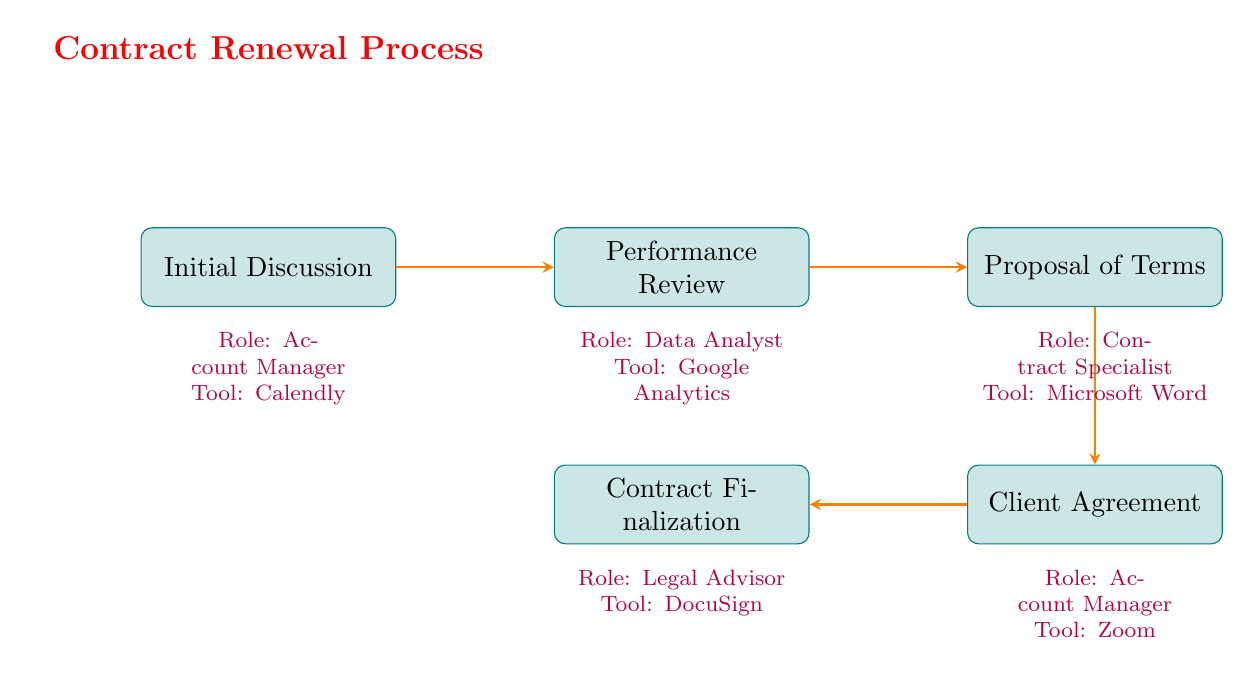What is the first stage in the contract renewal process? According to the diagram, the first stage listed is "Initial Discussion." This can be identified as it is the leftmost node in the flow chart.
Answer: Initial Discussion Who is responsible for the Performance Review? The diagram indicates that the role responsible for the Performance Review stage is the "Data Analyst." This is shown directly below the Performance Review node.
Answer: Data Analyst What tool is used during the Proposal of Terms stage? The diagram specifies that the tool used in the Proposal of Terms stage is "Microsoft Word." This information is underneath the corresponding node in the chart.
Answer: Microsoft Word How many stages are involved in the contract renewal process? The diagram clearly shows five distinct stages. Counting the nodes from left to right gives a total of five stages: Initial Discussion, Performance Review, Proposal of Terms, Client Agreement, and Contract Finalization.
Answer: 5 What is the last stage before Contract Finalization? Looking at the flow, the stage that comes immediately before Contract Finalization is "Client Agreement." This is indicated as the node that is directly above the final stage in the diagram.
Answer: Client Agreement What is the relationship between Proposal of Terms and Contract Finalization? The Proposal of Terms stage precedes the Client Agreement, which in turn leads to Contract Finalization. The arrows in the diagram indicate a sequential flow from Proposal of Terms down to Contract Finalization.
Answer: Sequential Which two roles are the same in the diagram? Both the "Account Manager" roles appear in the Initial Discussion and Client Agreement stages as indicated below each of those nodes.
Answer: Account Manager What is the activity conducted during the Initial Discussion? The activity listed for the Initial Discussion stage is "Schedule Meeting." This is explicitly stated below the Initial Discussion node in the diagram.
Answer: Schedule Meeting 